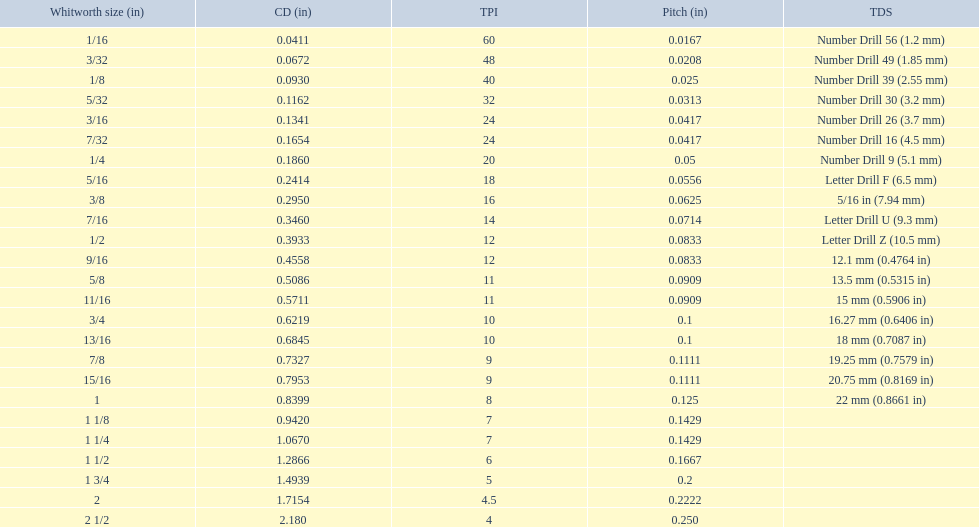What are all of the whitworth sizes in the british standard whitworth? 1/16, 3/32, 1/8, 5/32, 3/16, 7/32, 1/4, 5/16, 3/8, 7/16, 1/2, 9/16, 5/8, 11/16, 3/4, 13/16, 7/8, 15/16, 1, 1 1/8, 1 1/4, 1 1/2, 1 3/4, 2, 2 1/2. Which of these sizes uses a tapping drill size of 26? 3/16. 